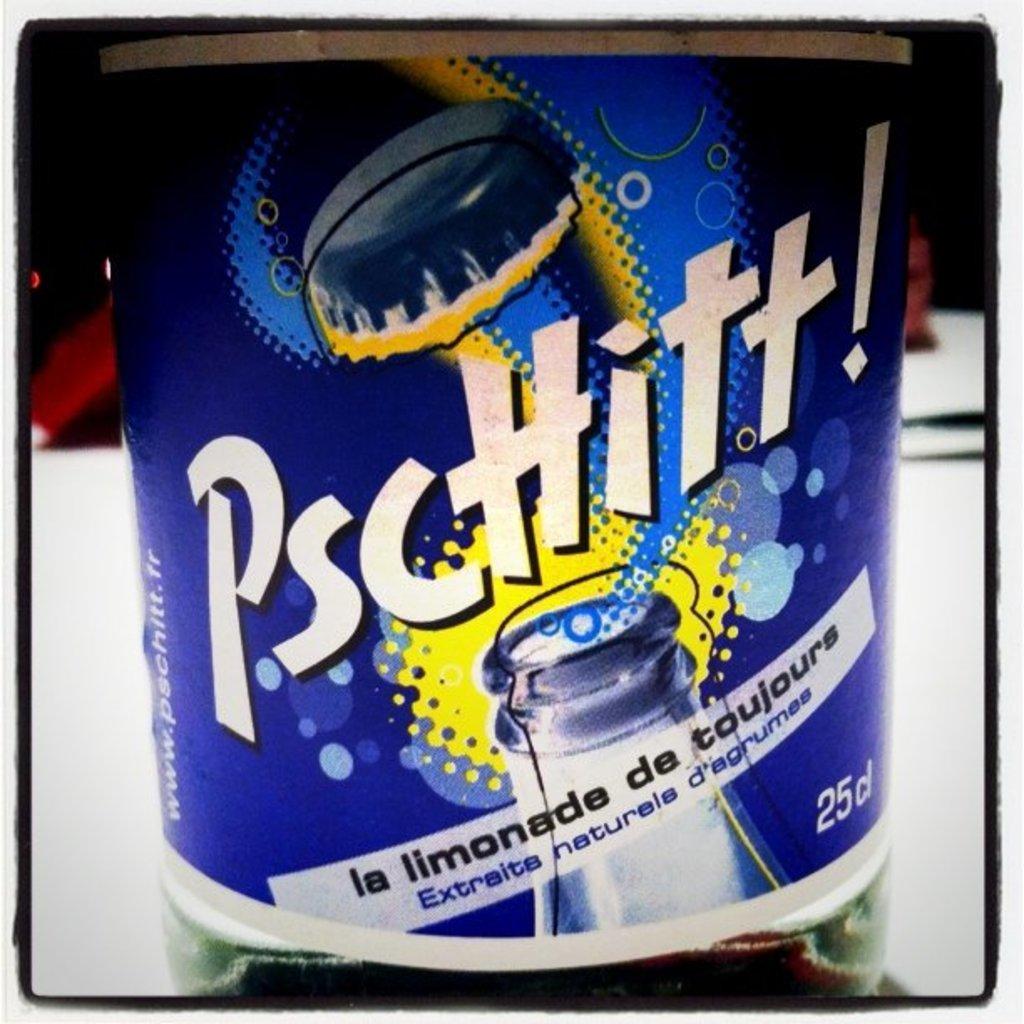What are the words on the bottle?
Give a very brief answer. Pschitt. Does pschitt have calorie information on it?
Keep it short and to the point. No. 